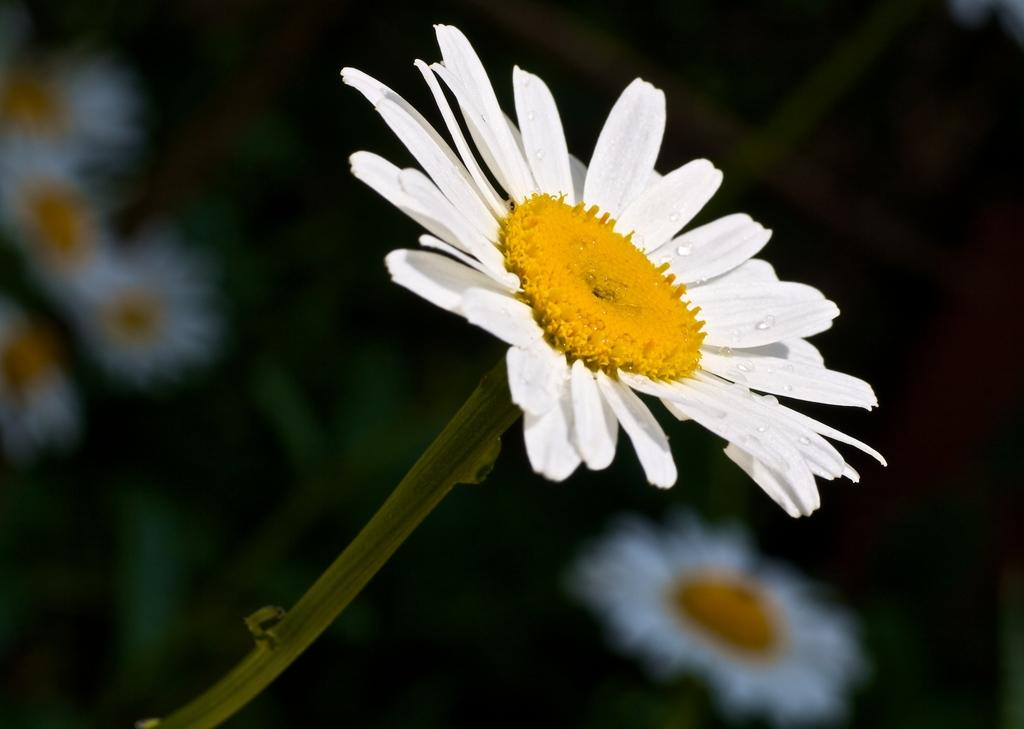What type of living organisms can be seen in the image? There are flowers in the image. Can you describe the background of the image? The background of the image is blurry. How many chairs are visible in the image? There are no chairs present in the image; it only features flowers and a blurry background. What type of flock can be seen flying in the image? There is no flock of birds or any other animals visible in the image; it only features flowers and a blurry background. 